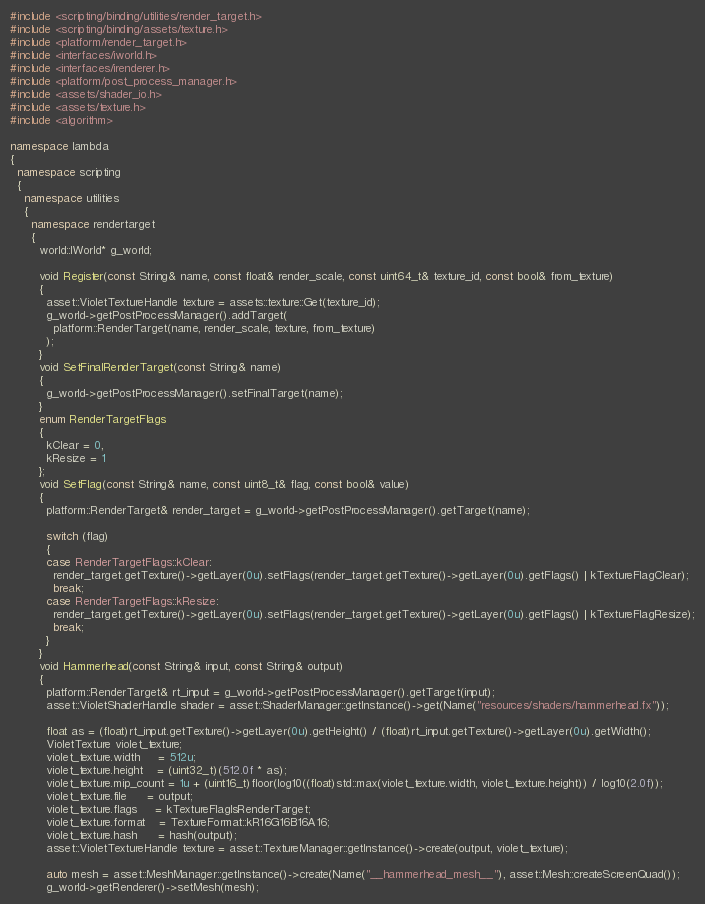Convert code to text. <code><loc_0><loc_0><loc_500><loc_500><_C++_>#include <scripting/binding/utilities/render_target.h>
#include <scripting/binding/assets/texture.h>
#include <platform/render_target.h>
#include <interfaces/iworld.h>
#include <interfaces/irenderer.h>
#include <platform/post_process_manager.h>
#include <assets/shader_io.h>
#include <assets/texture.h>
#include <algorithm>

namespace lambda
{
  namespace scripting
  {
    namespace utilities
    {
      namespace rendertarget
      {
        world::IWorld* g_world;

        void Register(const String& name, const float& render_scale, const uint64_t& texture_id, const bool& from_texture)
        {
          asset::VioletTextureHandle texture = assets::texture::Get(texture_id);
          g_world->getPostProcessManager().addTarget(
            platform::RenderTarget(name, render_scale, texture, from_texture)
          );
        }
        void SetFinalRenderTarget(const String& name)
        {
          g_world->getPostProcessManager().setFinalTarget(name);
        }
        enum RenderTargetFlags
        {
          kClear = 0,
          kResize = 1
        };
        void SetFlag(const String& name, const uint8_t& flag, const bool& value)
        {
          platform::RenderTarget& render_target = g_world->getPostProcessManager().getTarget(name);

          switch (flag)
          {
          case RenderTargetFlags::kClear:
            render_target.getTexture()->getLayer(0u).setFlags(render_target.getTexture()->getLayer(0u).getFlags() | kTextureFlagClear);
            break;
          case RenderTargetFlags::kResize:
            render_target.getTexture()->getLayer(0u).setFlags(render_target.getTexture()->getLayer(0u).getFlags() | kTextureFlagResize);
            break;
          }
        }
        void Hammerhead(const String& input, const String& output)
        {
          platform::RenderTarget& rt_input = g_world->getPostProcessManager().getTarget(input);
          asset::VioletShaderHandle shader = asset::ShaderManager::getInstance()->get(Name("resources/shaders/hammerhead.fx"));

          float as = (float)rt_input.getTexture()->getLayer(0u).getHeight() / (float)rt_input.getTexture()->getLayer(0u).getWidth();
          VioletTexture violet_texture;
          violet_texture.width     = 512u;
          violet_texture.height    = (uint32_t)(512.0f * as);
          violet_texture.mip_count = 1u + (uint16_t)floor(log10((float)std::max(violet_texture.width, violet_texture.height)) / log10(2.0f));
          violet_texture.file      = output;
          violet_texture.flags     = kTextureFlagIsRenderTarget;
          violet_texture.format    = TextureFormat::kR16G16B16A16;
          violet_texture.hash      = hash(output);
          asset::VioletTextureHandle texture = asset::TextureManager::getInstance()->create(output, violet_texture);

          auto mesh = asset::MeshManager::getInstance()->create(Name("__hammerhead_mesh__"), asset::Mesh::createScreenQuad());
          g_world->getRenderer()->setMesh(mesh);</code> 